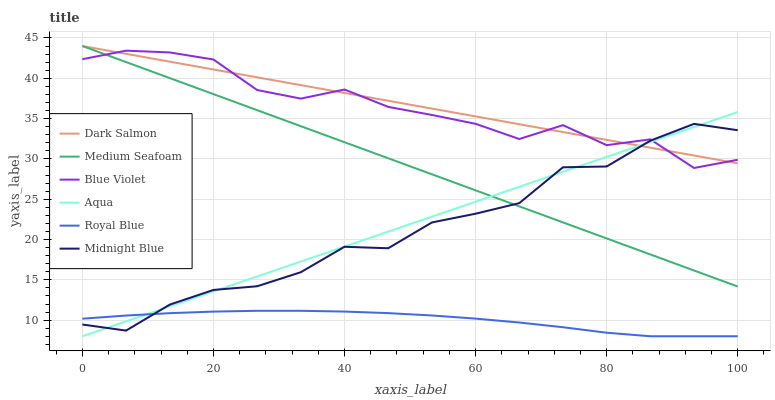Does Aqua have the minimum area under the curve?
Answer yes or no. No. Does Aqua have the maximum area under the curve?
Answer yes or no. No. Is Aqua the smoothest?
Answer yes or no. No. Is Aqua the roughest?
Answer yes or no. No. Does Dark Salmon have the lowest value?
Answer yes or no. No. Does Aqua have the highest value?
Answer yes or no. No. Is Royal Blue less than Blue Violet?
Answer yes or no. Yes. Is Medium Seafoam greater than Royal Blue?
Answer yes or no. Yes. Does Royal Blue intersect Blue Violet?
Answer yes or no. No. 